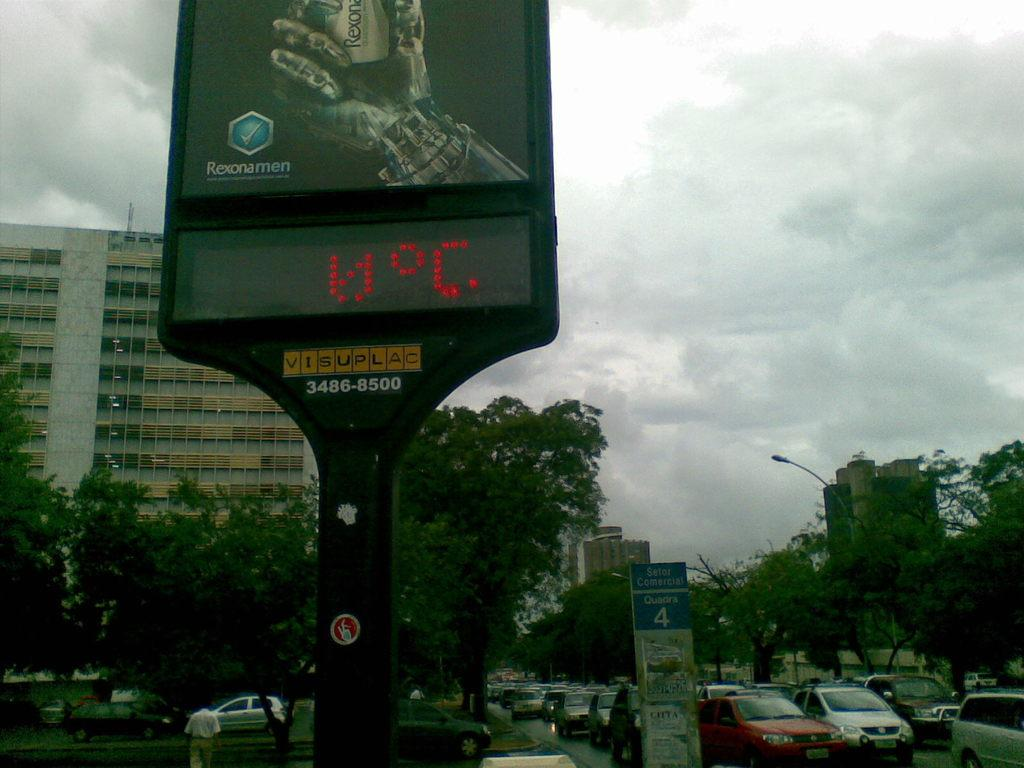What can be seen on the road in the image? There are vehicles on the road in the image. What type of natural elements are visible in the image? There are trees visible in the image. What type of man-made structures can be seen in the image? There are buildings, hoardings, posters, and a digital board in the image. What is the condition of the sky in the image? The sky is cloudy in the image. What else can be seen in the image besides the vehicles and structures? There is a light pole and a person in the image. What type of produce is being harvested in the image? There is no produce being harvested in the image; it features vehicles, trees, buildings, hoardings, posters, a digital board, a light pole, and a person. What type of needle can be seen being used by the person in the image? There is no needle present in the image; it only features a person, not any specific activity or tool. 